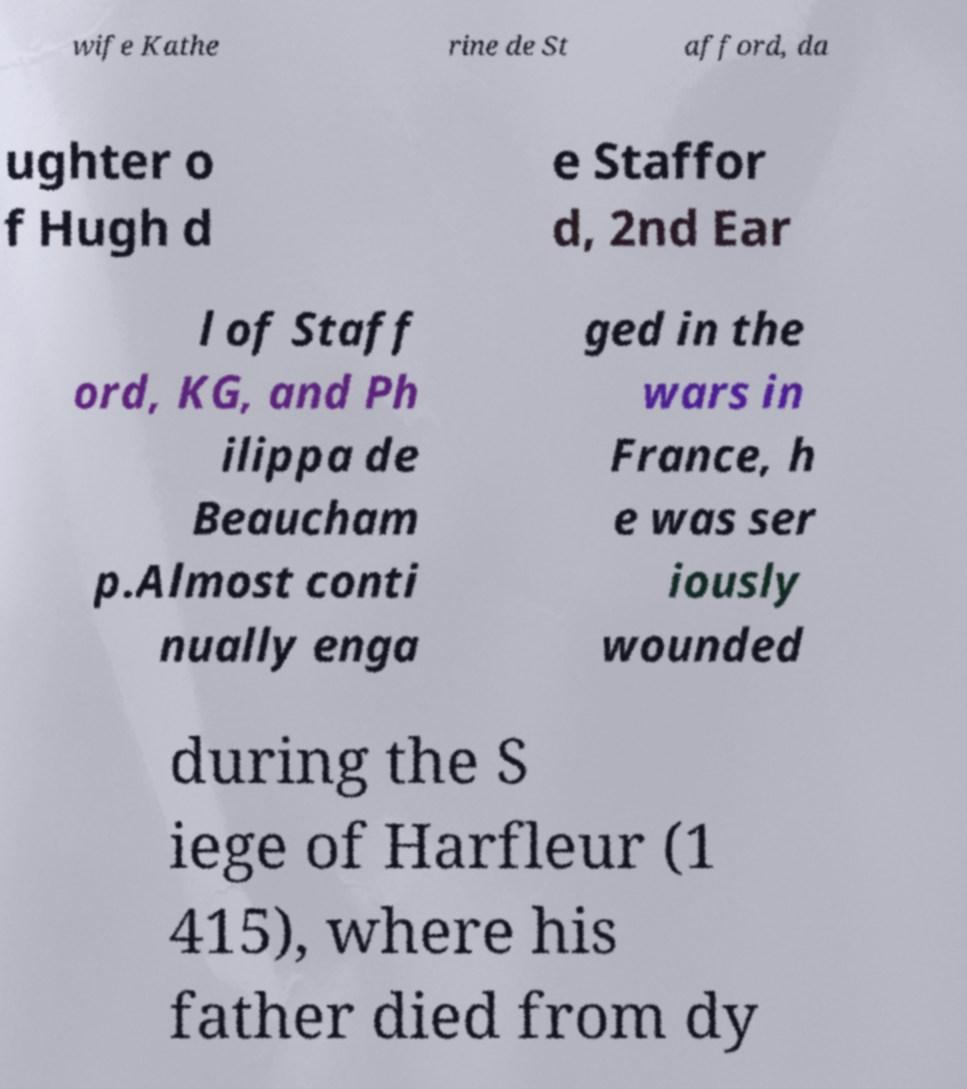Can you accurately transcribe the text from the provided image for me? wife Kathe rine de St afford, da ughter o f Hugh d e Staffor d, 2nd Ear l of Staff ord, KG, and Ph ilippa de Beaucham p.Almost conti nually enga ged in the wars in France, h e was ser iously wounded during the S iege of Harfleur (1 415), where his father died from dy 